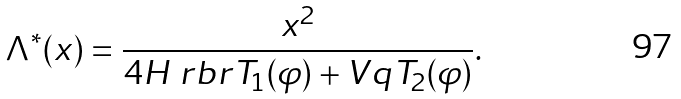Convert formula to latex. <formula><loc_0><loc_0><loc_500><loc_500>\Lambda ^ { * } ( x ) = \frac { x ^ { 2 } } { 4 H \ r b r { T _ { 1 } ( \varphi ) + V q T _ { 2 } ( \varphi ) } } .</formula> 